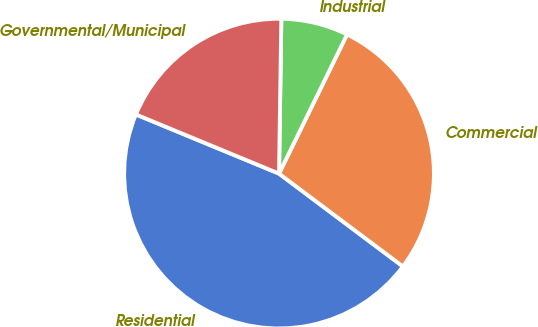Convert chart. <chart><loc_0><loc_0><loc_500><loc_500><pie_chart><fcel>Residential<fcel>Commercial<fcel>Industrial<fcel>Governmental/Municipal<nl><fcel>46.0%<fcel>28.0%<fcel>7.0%<fcel>19.0%<nl></chart> 